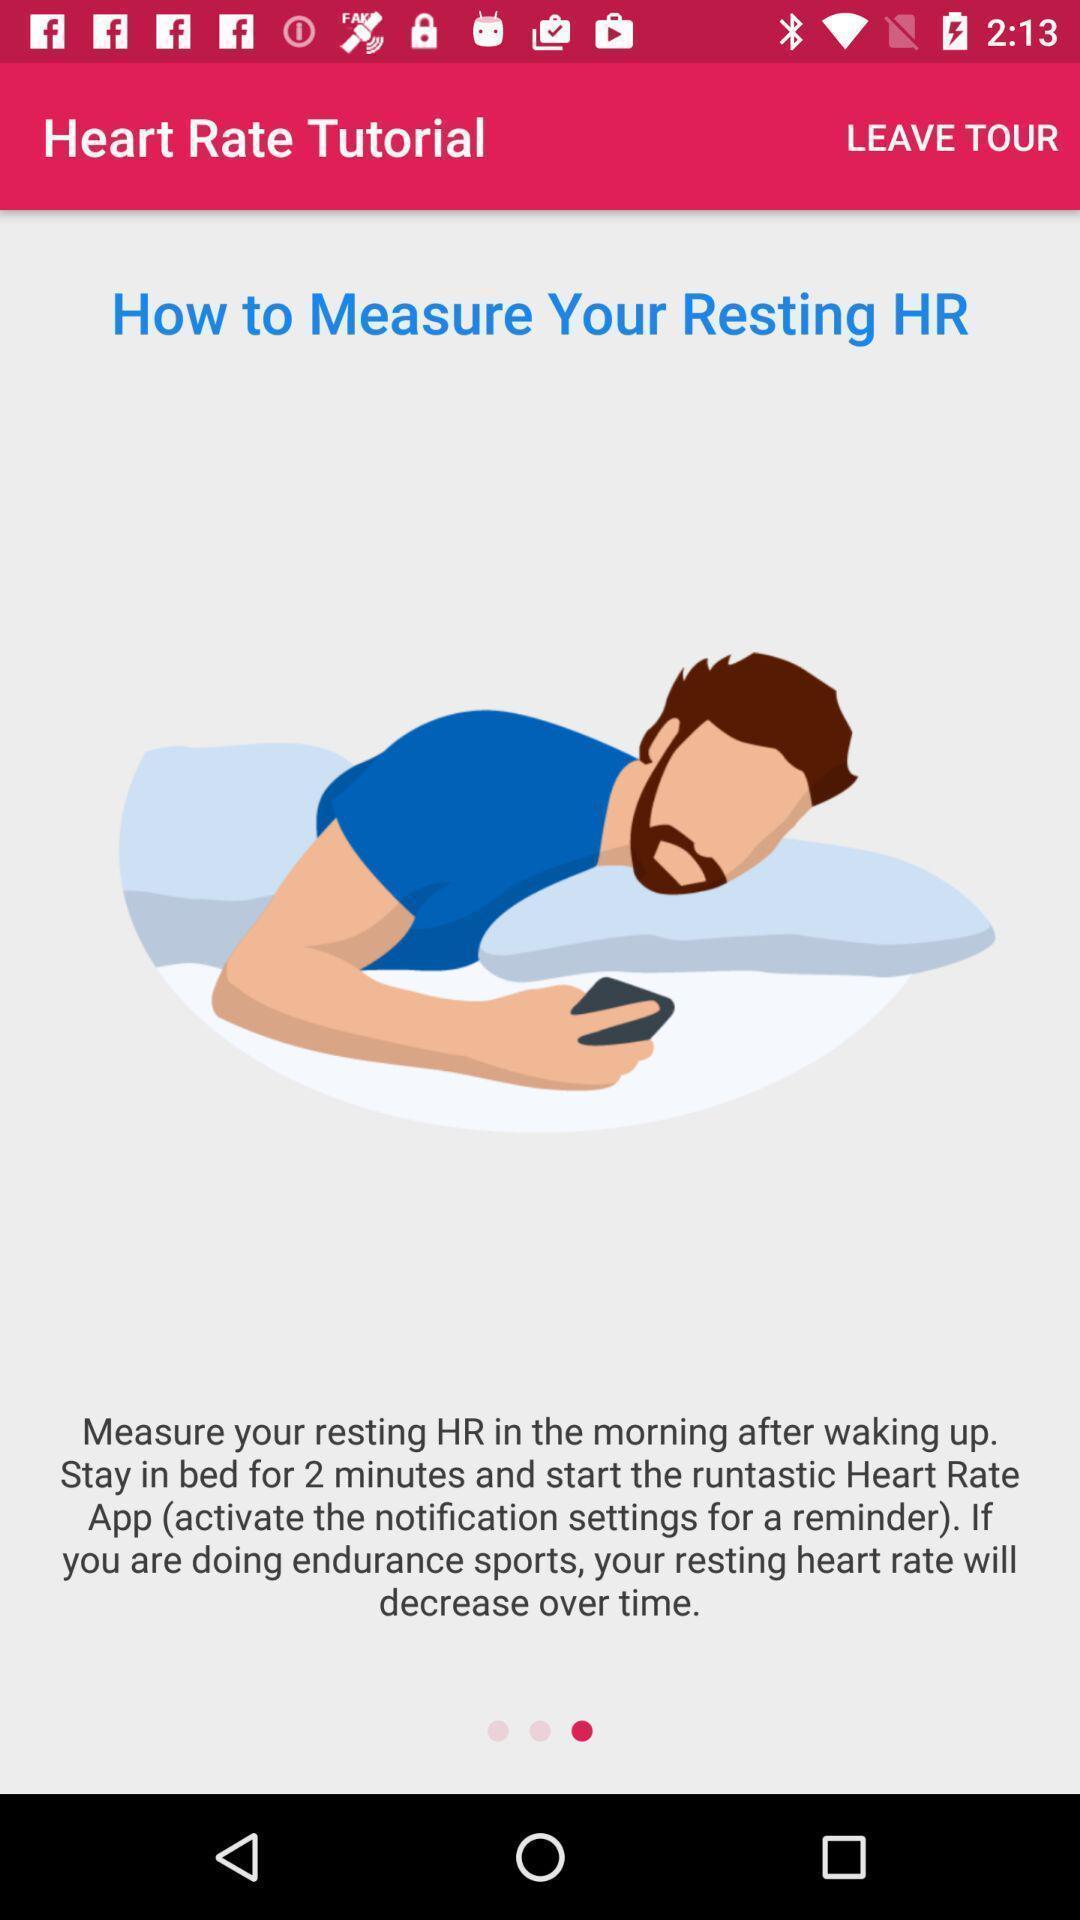Give me a narrative description of this picture. Page showing about how to measure heart rate. 